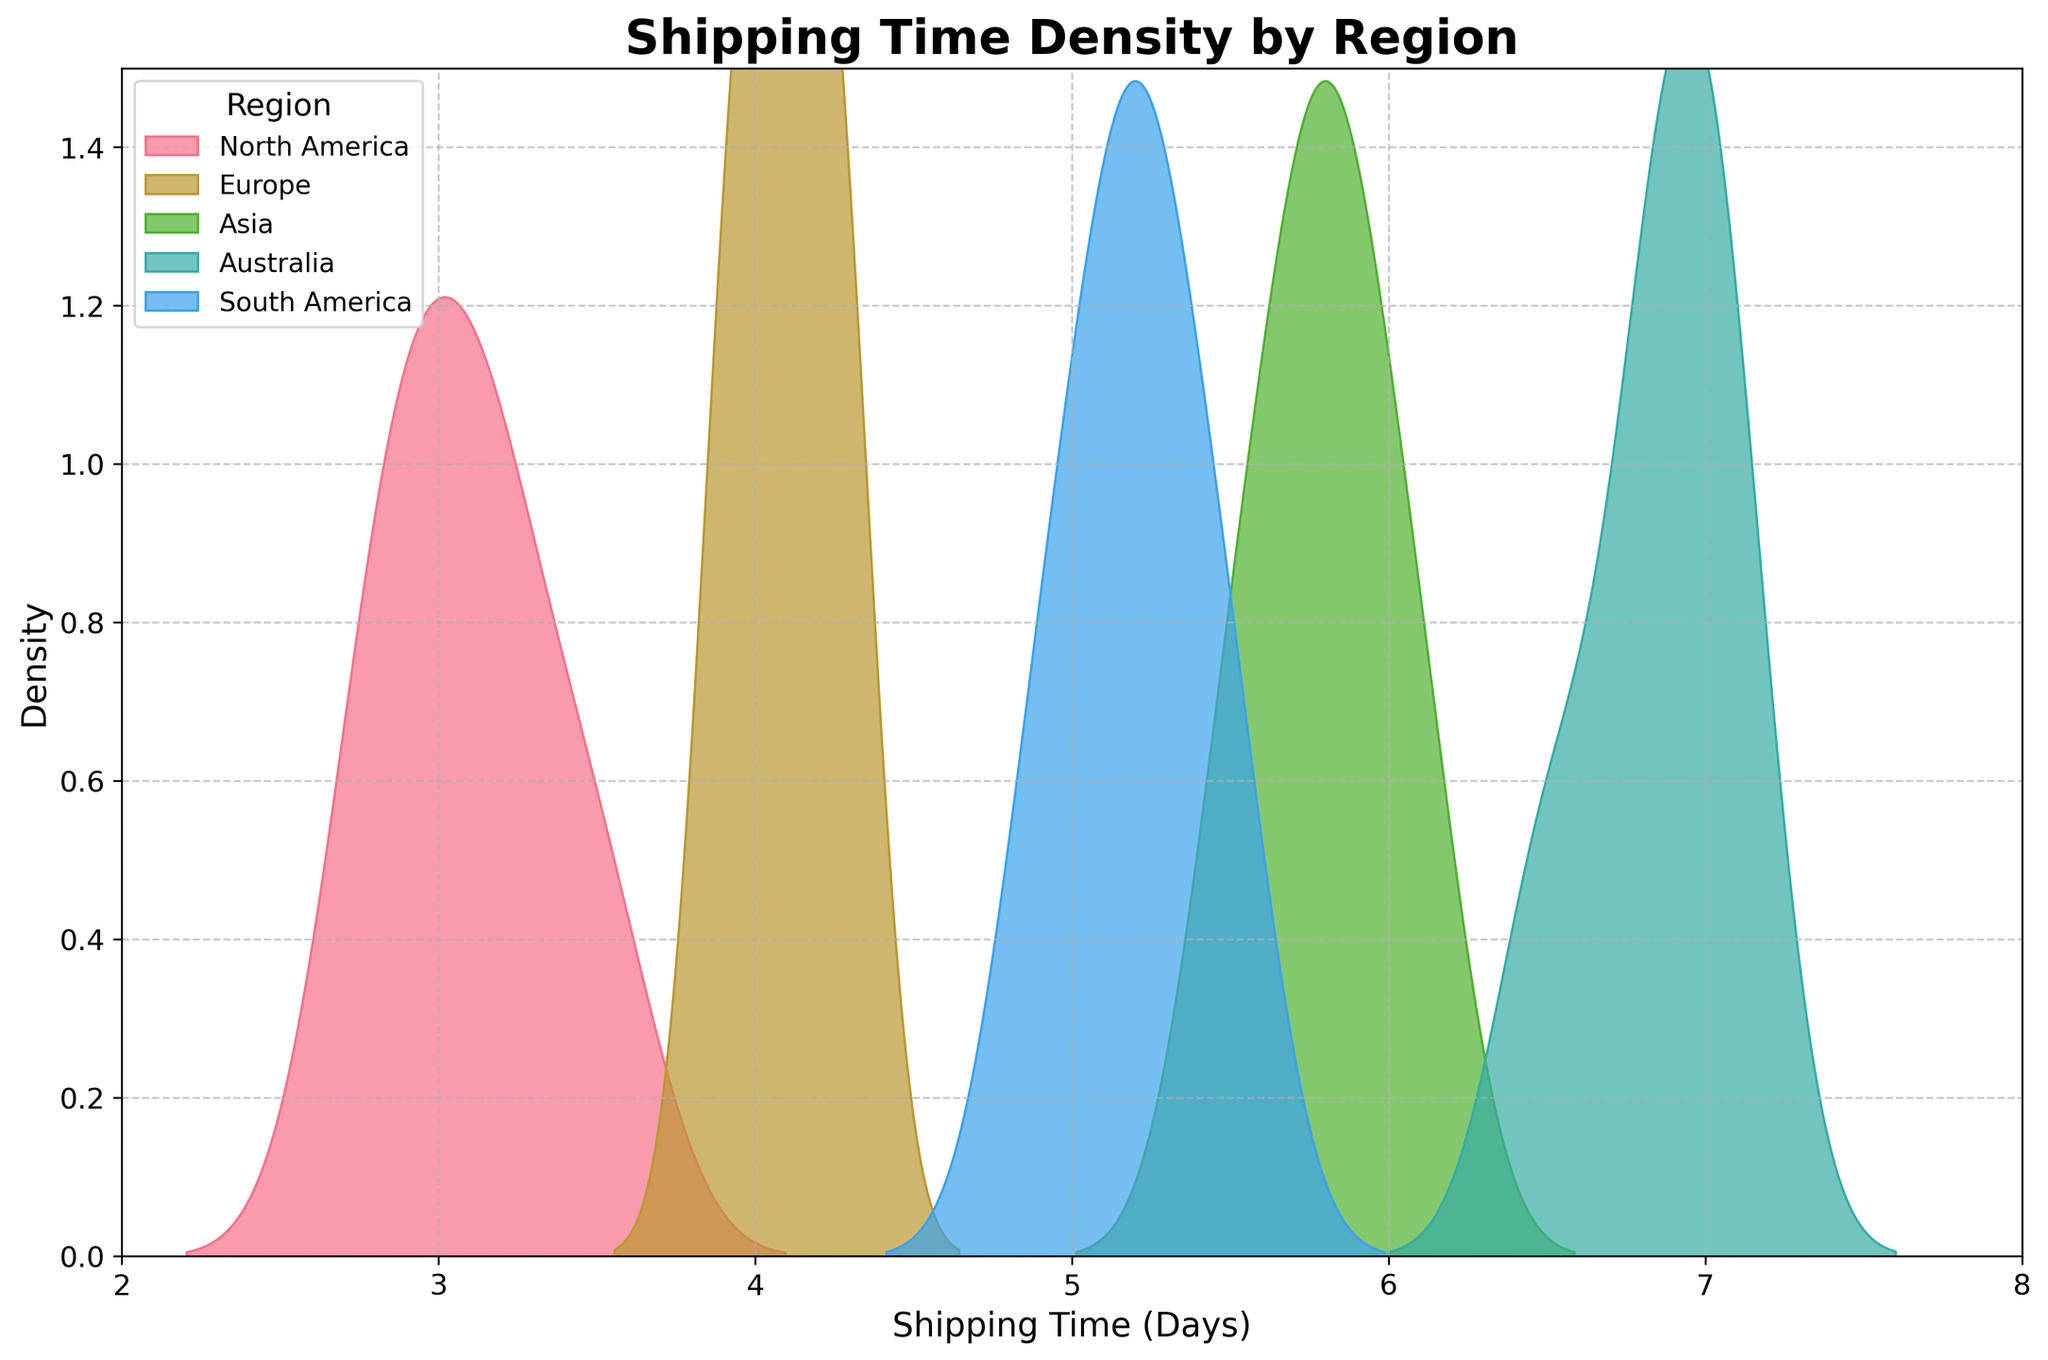What is the title of the density plot? The title of the density plot is shown at the top of the figure.
Answer: Shipping Time Density by Region What does the x-axis represent? The x-axis label is shown below the axis in the figure.
Answer: Shipping Time (Days) Which region has the highest density peak for shipping time? The highest density peak for a region is the tallest peak in the density plot for that region. The region with the highest peak is the one with the highest shipping time density.
Answer: Europe What is the approximate range of shipping times for North America? Check the x-axis range covered by the shaded region representing North America. The range can be identified from the start and end points of the shaded area.
Answer: 2.8 to 3.5 days Which region has the widest range of shipping times? The widest range of shipping times can be identified by seeing which region's shaded area spreads the most along the x-axis.
Answer: Asia How does the shipping time in North America compare to Europe? Compare the location and spread of the density peaks between North America and Europe on the x-axis. North America’s shipping times are generally lower than Europe.
Answer: North America's shipping times are lower on average than Europe's Is the shipping time distribution for Australia skewed? If so, in which direction? Analyze the shape of the density curve for Australia. If it leans more towards one side, it is skewed. Australia’s density curve leans towards the right, indicating it is positively skewed.
Answer: Positively skewed Which region has the lowest minimum shipping time? Identify the leftmost point on the x-axis for each region's density plot. The region with the lowest leftmost point has the lowest minimum shipping time.
Answer: North America What is the approximate shipping time range that covers most of the density for South America? Look at where the bulk of the shaded region is for South America on the x-axis. This indicates the range where most shipping times fall for South America.
Answer: 4.9 to 5.5 days How do the shipping times in Asia compare to those in South America? Compare the location and spread of the density peaks between Asia and South America on the x-axis. Asia’s shipping times are generally higher than South America.
Answer: Asia’s shipping times are higher on average than South America's 